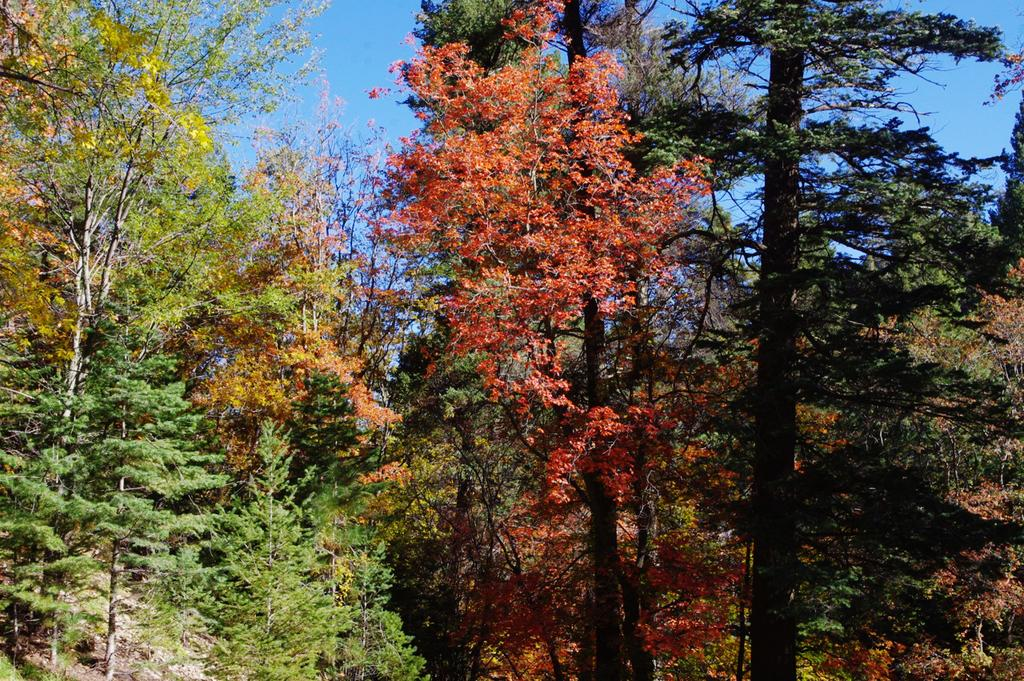What type of vegetation can be seen in the image? There are trees in the image. What type of paste is being used to construct the building in the image? There is no building present in the image, and therefore no construction or paste can be observed. 